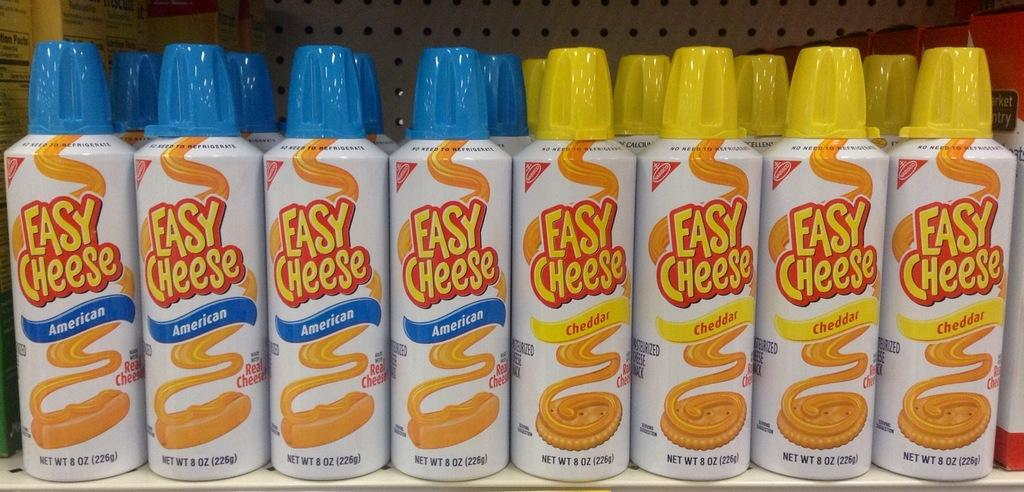<image>
Render a clear and concise summary of the photo. A display of Easy Cheese is organized by American and Cheddar flavors. 